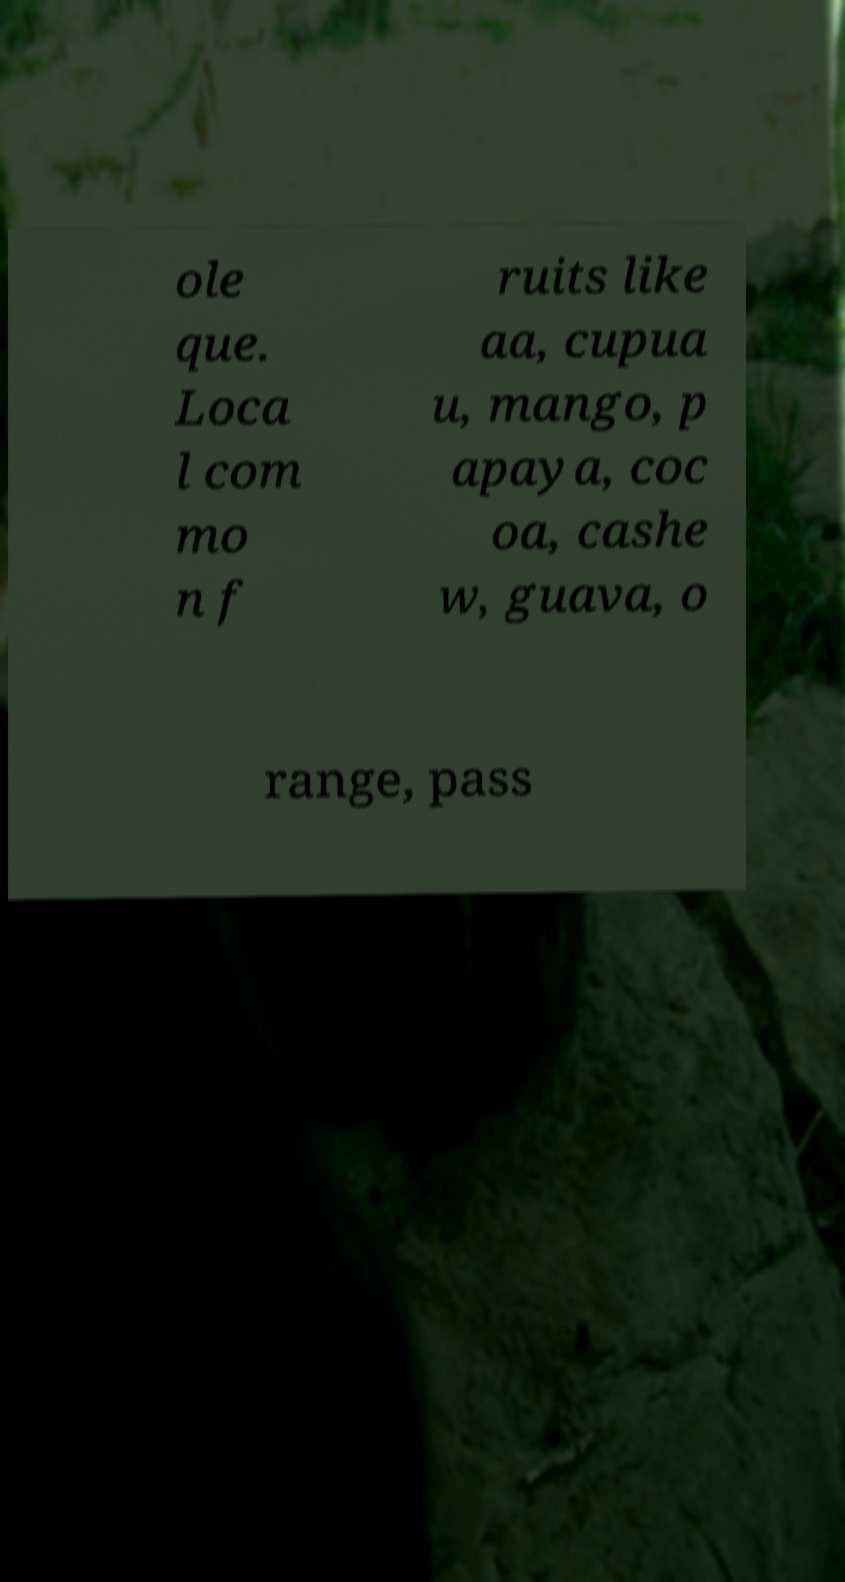For documentation purposes, I need the text within this image transcribed. Could you provide that? ole que. Loca l com mo n f ruits like aa, cupua u, mango, p apaya, coc oa, cashe w, guava, o range, pass 